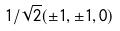Convert formula to latex. <formula><loc_0><loc_0><loc_500><loc_500>1 / \sqrt { 2 } ( \pm 1 , \pm 1 , 0 )</formula> 